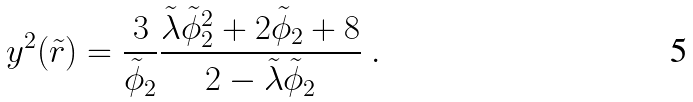Convert formula to latex. <formula><loc_0><loc_0><loc_500><loc_500>y ^ { 2 } ( \tilde { r } ) = \frac { 3 } { { \tilde { \phi } } _ { 2 } } \frac { \tilde { \lambda } { \tilde { \phi } } ^ { 2 } _ { 2 } + 2 { \tilde { \phi } } _ { 2 } + 8 } { 2 - \tilde { \lambda } { \tilde { \phi } } _ { 2 } } \ .</formula> 